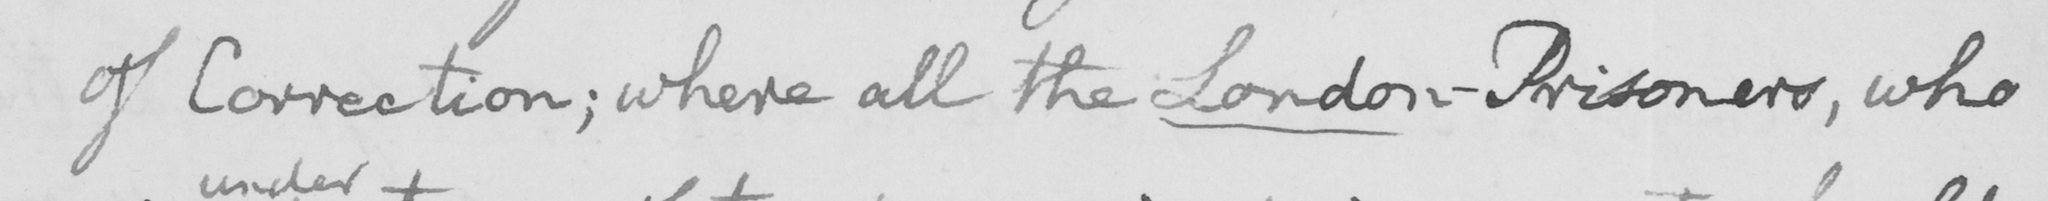Can you read and transcribe this handwriting? of Correction; where all the London-Prisoners, who 